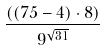<formula> <loc_0><loc_0><loc_500><loc_500>\frac { ( ( 7 5 - 4 ) \cdot 8 ) } { 9 ^ { \sqrt { 3 1 } } }</formula> 